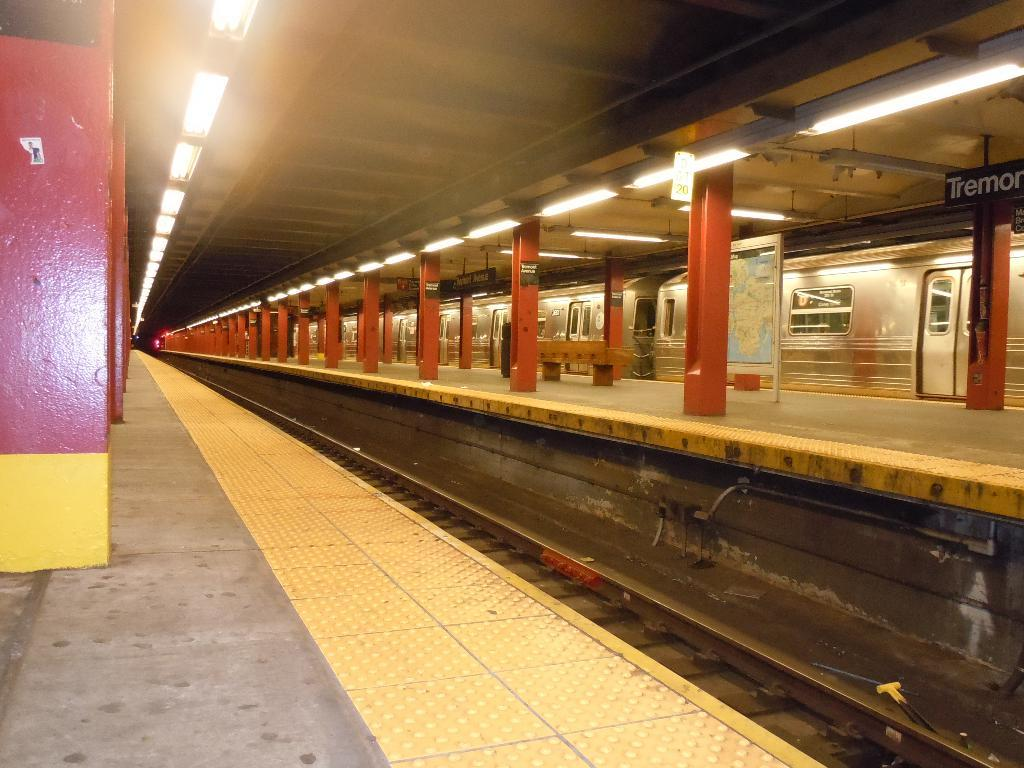What type of location is shown in the image? The image depicts a railway station. What can be seen illuminated in the image? There are lights in the image. What structural elements are visible in the image? Pillars are visible in the image. What is the primary mode of transportation associated with the location? Train tracks are present in the image. Can a train be seen in the image? Yes, there is a train in the image. What type of signage is visible in the image? Boards are visible in the image. What surface is present beneath the various objects and structures in the image? There is a floor in the image. Can you tell me what type of record the stranger is holding in the image? There is no stranger or record present in the image. 